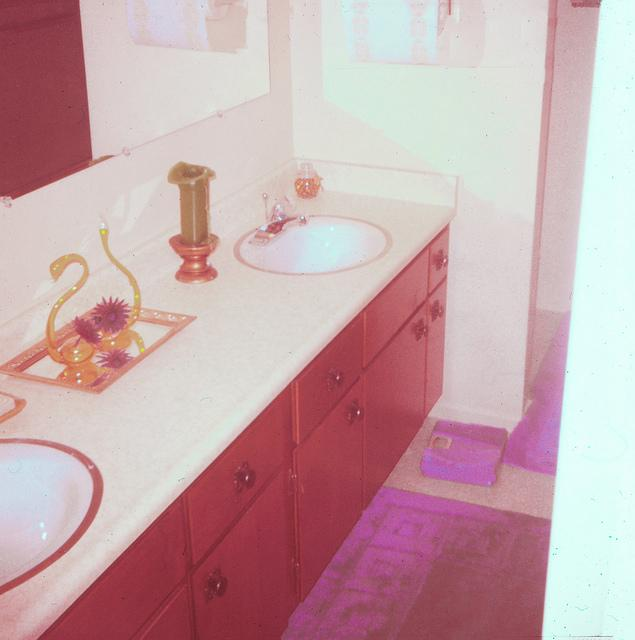What item on the counter has melted? Please explain your reasoning. candle. There is nothing left in the candlestick so the candle must have melted. 